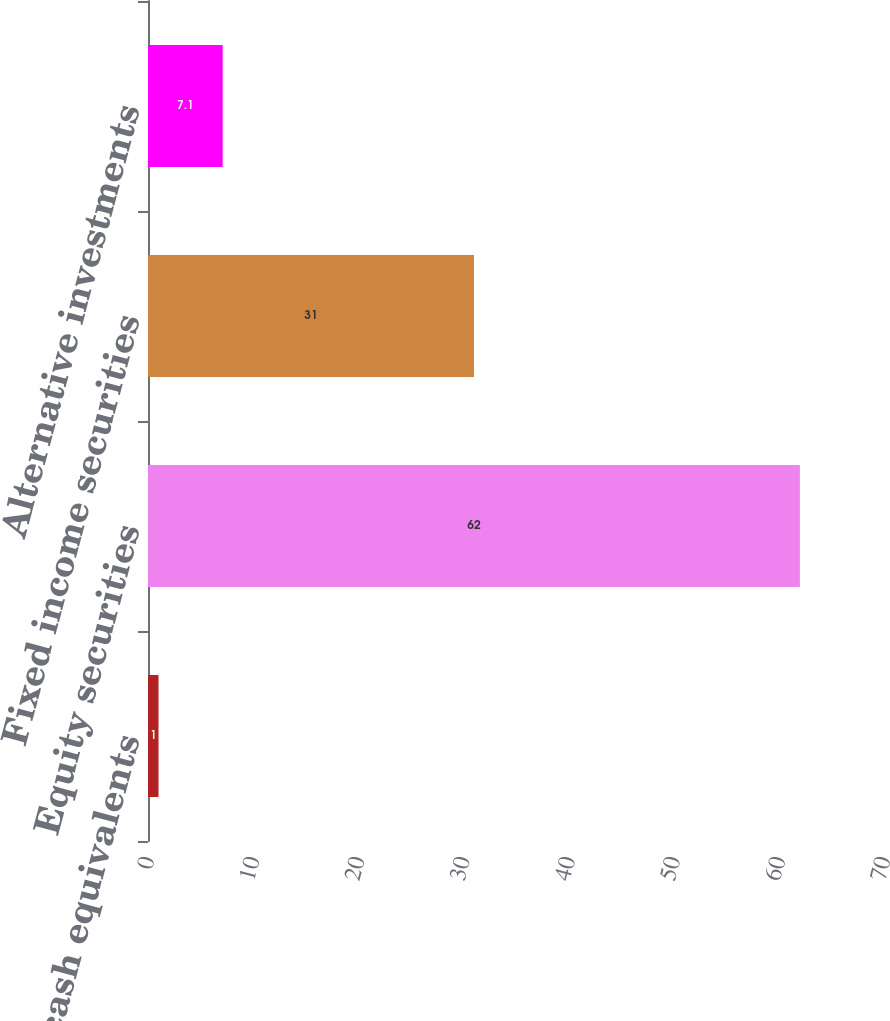Convert chart. <chart><loc_0><loc_0><loc_500><loc_500><bar_chart><fcel>Cash and cash equivalents<fcel>Equity securities<fcel>Fixed income securities<fcel>Alternative investments<nl><fcel>1<fcel>62<fcel>31<fcel>7.1<nl></chart> 